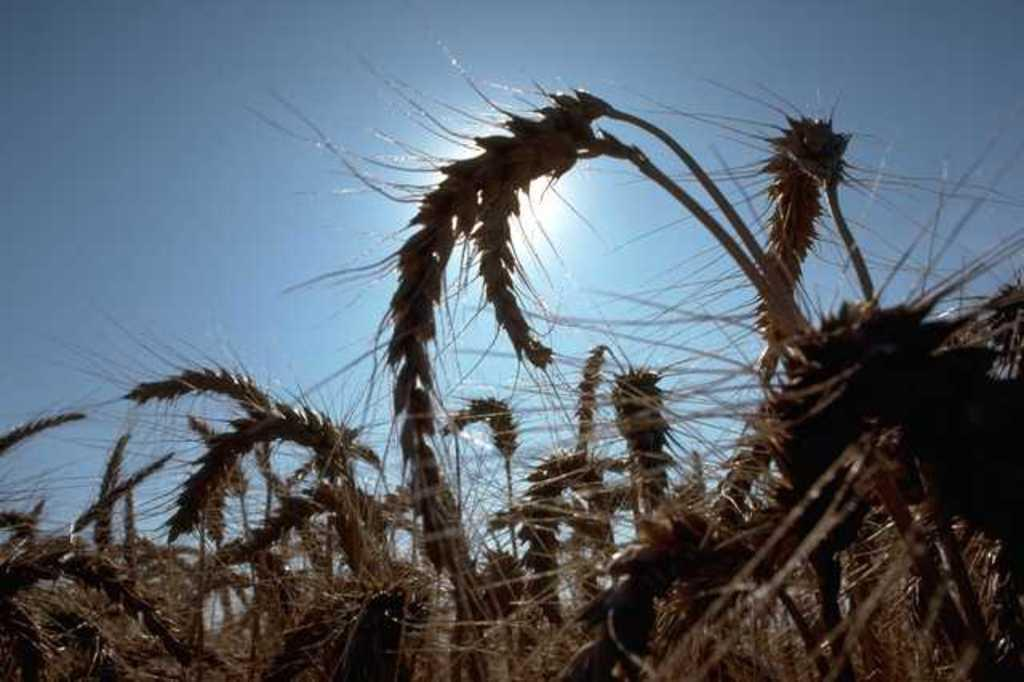What type of living organisms can be seen in the image? Plants can be seen in the image. What celestial body is visible in the image? The sun is visible in the image. What type of appliance can be seen in the image? There is no appliance present in the image. Can you describe the bird that is flying in the image? There is no bird present in the image. 